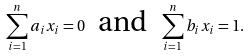<formula> <loc_0><loc_0><loc_500><loc_500>\sum _ { i = 1 } ^ { n } a _ { i } x _ { i } = 0 \text { \ and \ } \sum _ { i = 1 } ^ { n } b _ { i } x _ { i } = 1 .</formula> 